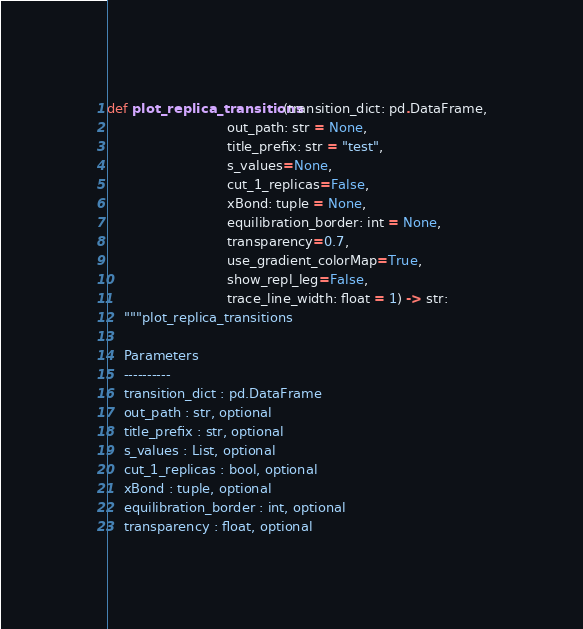<code> <loc_0><loc_0><loc_500><loc_500><_Python_>def plot_replica_transitions(transition_dict: pd.DataFrame,
                             out_path: str = None,
                             title_prefix: str = "test",
                             s_values=None,
                             cut_1_replicas=False,
                             xBond: tuple = None,
                             equilibration_border: int = None,
                             transparency=0.7,
                             use_gradient_colorMap=True,
                             show_repl_leg=False,
                             trace_line_width: float = 1) -> str:
    """plot_replica_transitions

    Parameters
    ----------
    transition_dict : pd.DataFrame
    out_path : str, optional
    title_prefix : str, optional
    s_values : List, optional
    cut_1_replicas : bool, optional
    xBond : tuple, optional
    equilibration_border : int, optional
    transparency : float, optional</code> 